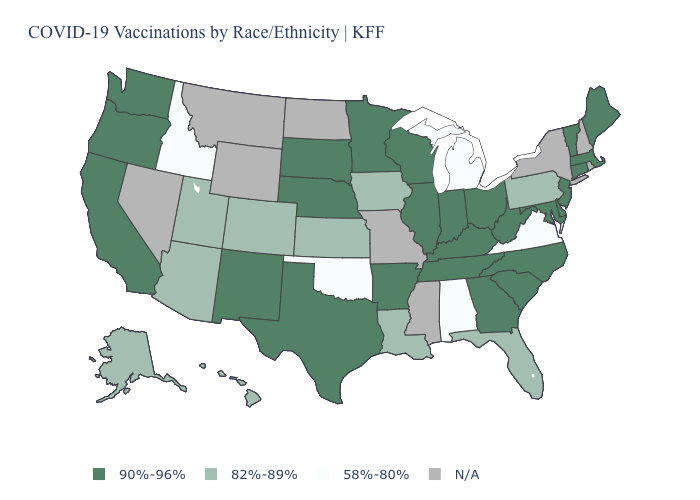Which states have the lowest value in the USA?
Keep it brief. Alabama, Idaho, Michigan, Oklahoma, Virginia. Does the first symbol in the legend represent the smallest category?
Write a very short answer. No. What is the value of Oregon?
Give a very brief answer. 90%-96%. How many symbols are there in the legend?
Concise answer only. 4. Among the states that border Washington , does Idaho have the lowest value?
Concise answer only. Yes. Name the states that have a value in the range N/A?
Write a very short answer. Mississippi, Missouri, Montana, Nevada, New Hampshire, New York, North Dakota, Rhode Island, Wyoming. Does Illinois have the lowest value in the USA?
Be succinct. No. Among the states that border Delaware , which have the highest value?
Concise answer only. Maryland, New Jersey. Does California have the highest value in the USA?
Short answer required. Yes. Name the states that have a value in the range 82%-89%?
Quick response, please. Alaska, Arizona, Colorado, Florida, Hawaii, Iowa, Kansas, Louisiana, Pennsylvania, Utah. Name the states that have a value in the range N/A?
Be succinct. Mississippi, Missouri, Montana, Nevada, New Hampshire, New York, North Dakota, Rhode Island, Wyoming. Does the first symbol in the legend represent the smallest category?
Quick response, please. No. Among the states that border New Jersey , does Pennsylvania have the highest value?
Write a very short answer. No. Does the map have missing data?
Write a very short answer. Yes. 